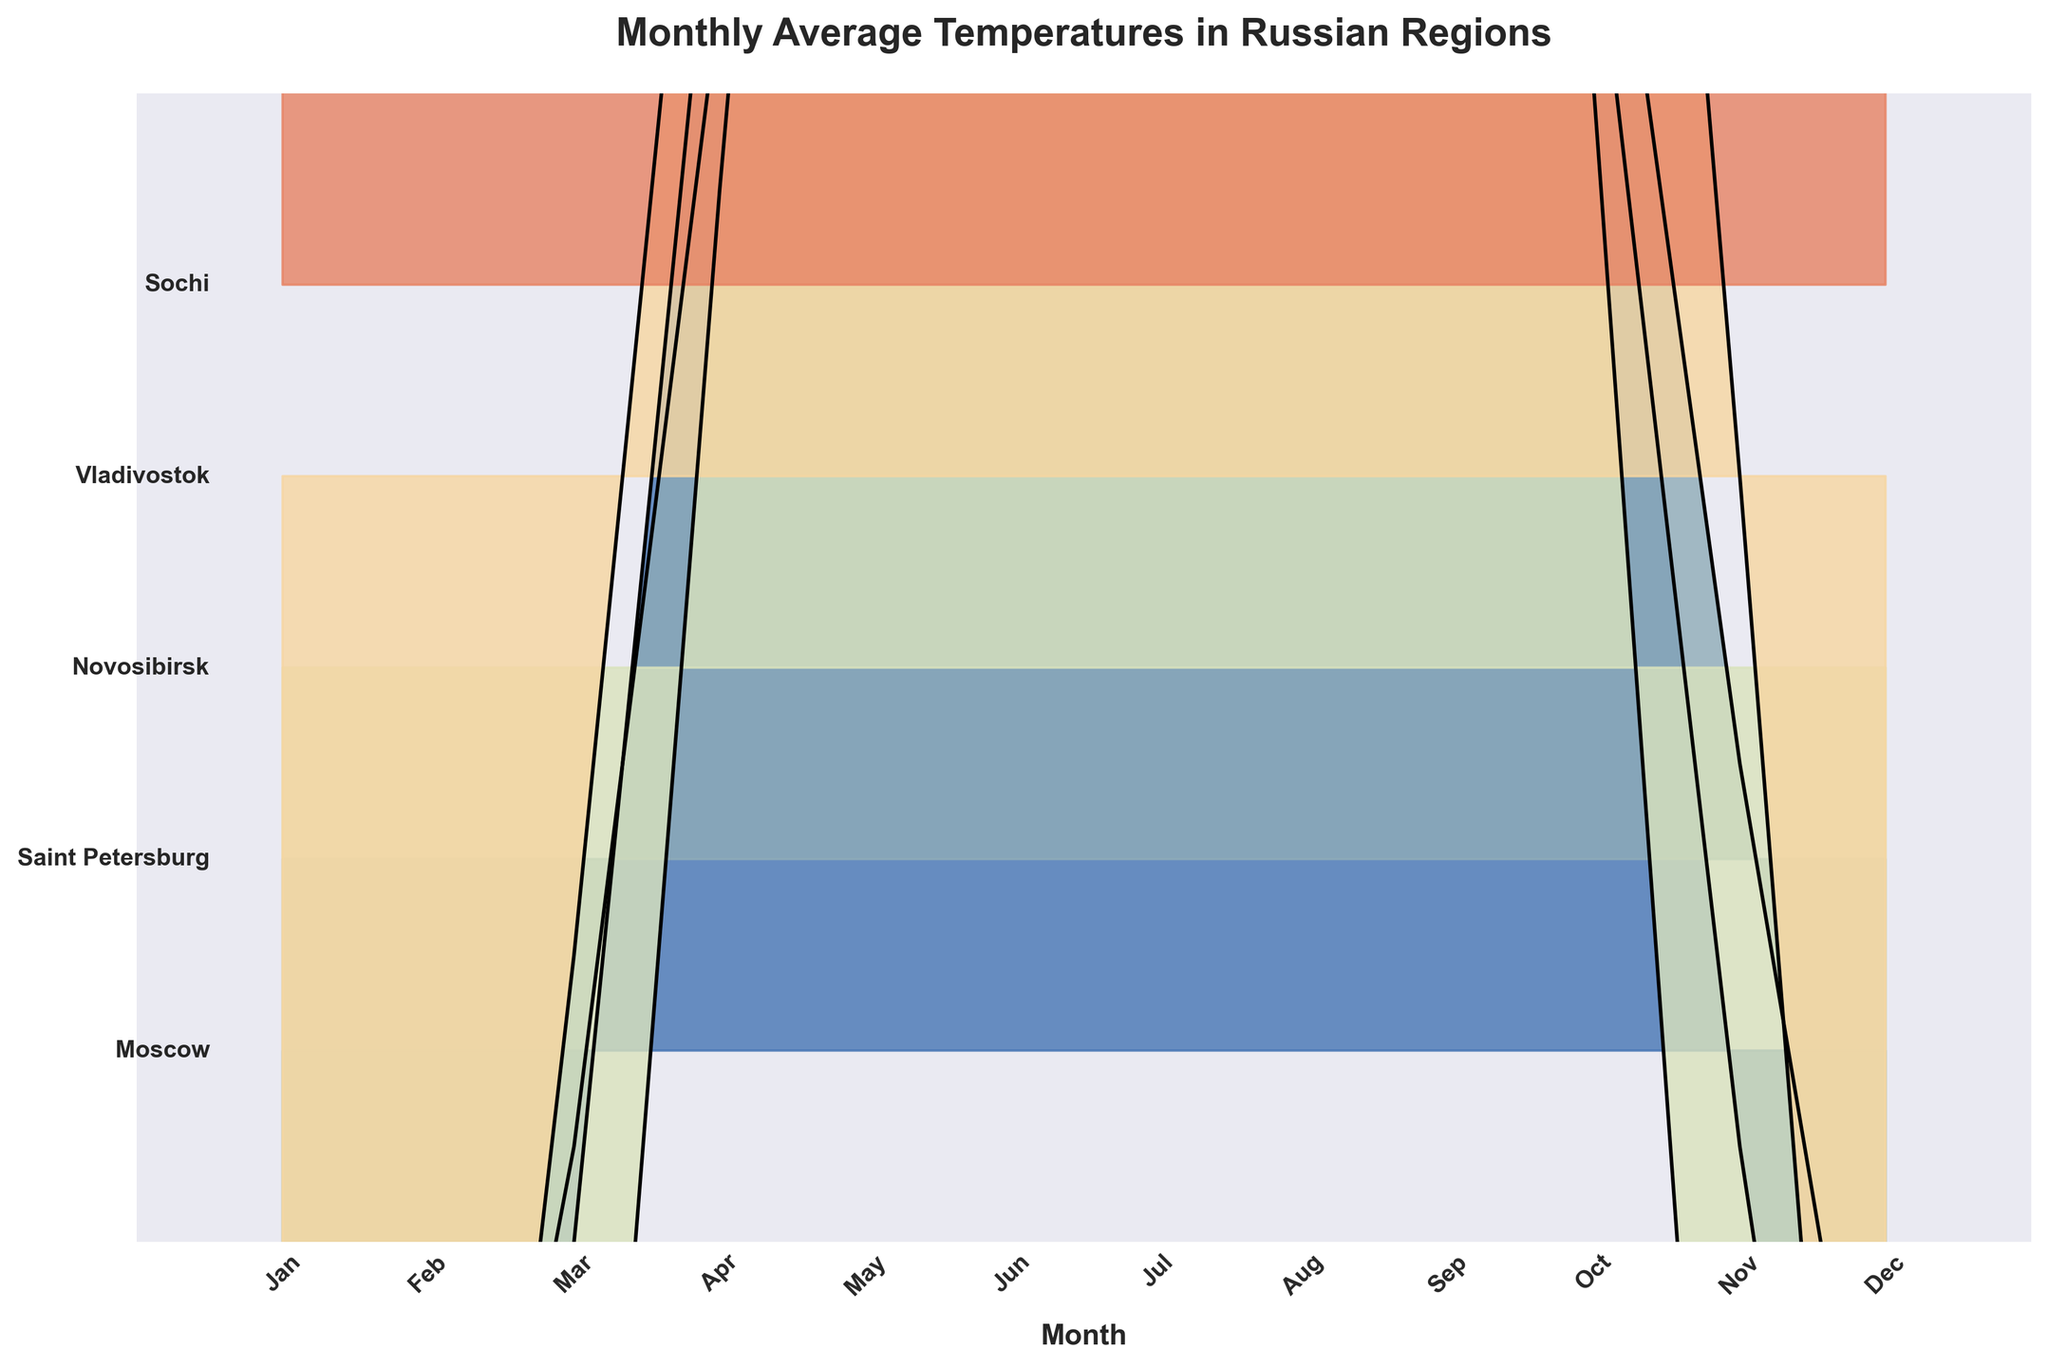Which region is the warmest in January? To determine the warmest region in January, look at the relative heights of the ridgeline plots for January. Sochi has the highest temperature in January among the regions.
Answer: Sochi What is the temperature difference between Moscow and Novosibirsk in January? Look at the temperature values for Moscow and Novosibirsk in January (-7.5°C for Moscow and -16.5°C for Novosibirsk). Subtract the two values: -7.5 - (-16.5) = 9°C.
Answer: 9°C In which month does Vladivostok experience its highest average temperature? Find the highest point in the Vladivostok ridgeline plot. This peak occurs in August, where the temperature is 21.0°C.
Answer: August Which regions have a noticeable temperature increase from April to July? Compare the changes in temperatures from April to July for each region. All regions show an increase, but noticeable ones are Moscow (6.5 to 19.5), Saint Petersburg (4.5 to 18.0), Novosibirsk (2.5 to 19.5), and Sochi (13.0 to 24.0).
Answer: Moscow, Saint Petersburg, Novosibirsk, Sochi How does the average temperature in Sochi in December compare to Moscow in December? Find the temperature values for Sochi and Moscow in December (8.5°C for Sochi and -5.5°C for Moscow). Sochi has a higher temperature.
Answer: Sochi is warmer Which region has the most significant variation in average monthly temperatures? Look at the range of temperatures for each region. Novosibirsk has the most significant variation from -16.5°C in January to 19.5°C in July.
Answer: Novosibirsk Between which two months does Saint Petersburg see the largest temperature increase? Compare temperature increases month by month for Saint Petersburg. The largest increase is from April to May (4.5°C to 11.0°C).
Answer: April to May What trend is observed generally in monthly temperatures from January to December? In all regions, temperatures increase from January through summer, peaking around July or August, then decrease through December.
Answer: Increase then decrease Is there any month where all regions are above 0°C? Assess the temperature values across all regions month by month. In July and August, all regions are above 0°C.
Answer: July, August How does the temperature in Saint Petersburg in November compare to Vladivostok in November? Look at the temperature values for November: Saint Petersburg (0.5°C) and Vladivostok (0.0°C). Saint Petersburg is slightly warmer.
Answer: Saint Petersburg is warmer 